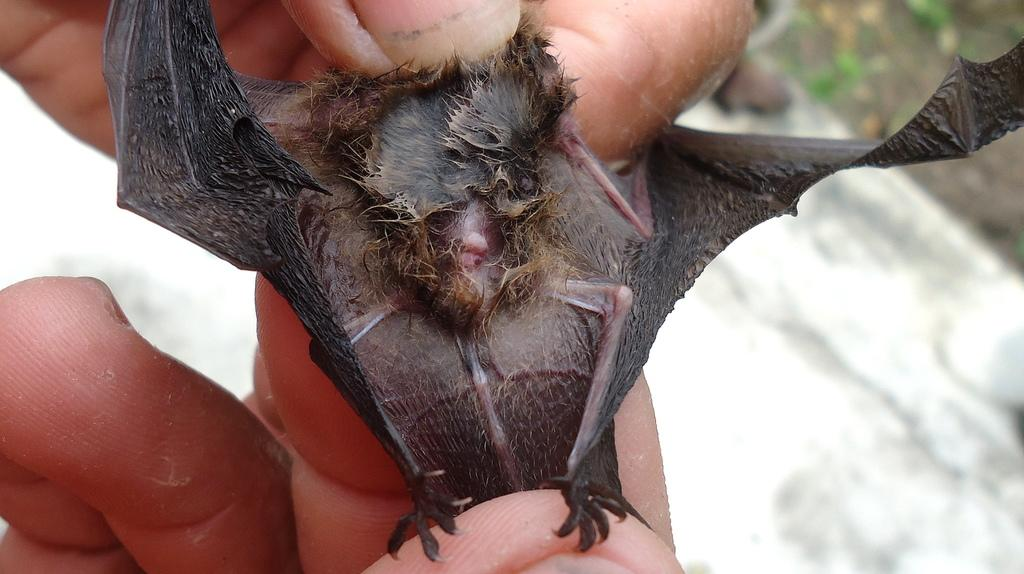What can be seen in the image that belongs to a person? There is a person's hand in the image. What is the hand holding? The hand is holding a bat. Can you describe the background of the image? The background of the image appears blurred. What type of crush is the person experiencing in the image? There is no indication of a crush or any emotions in the image; it only shows a person's hand holding a bat. 